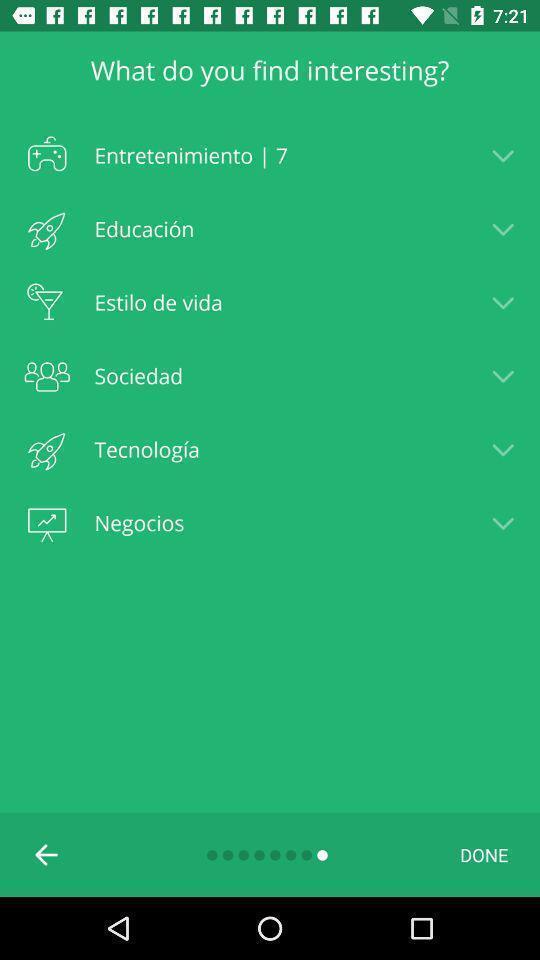Give me a summary of this screen capture. Screen displaying list of topics. 